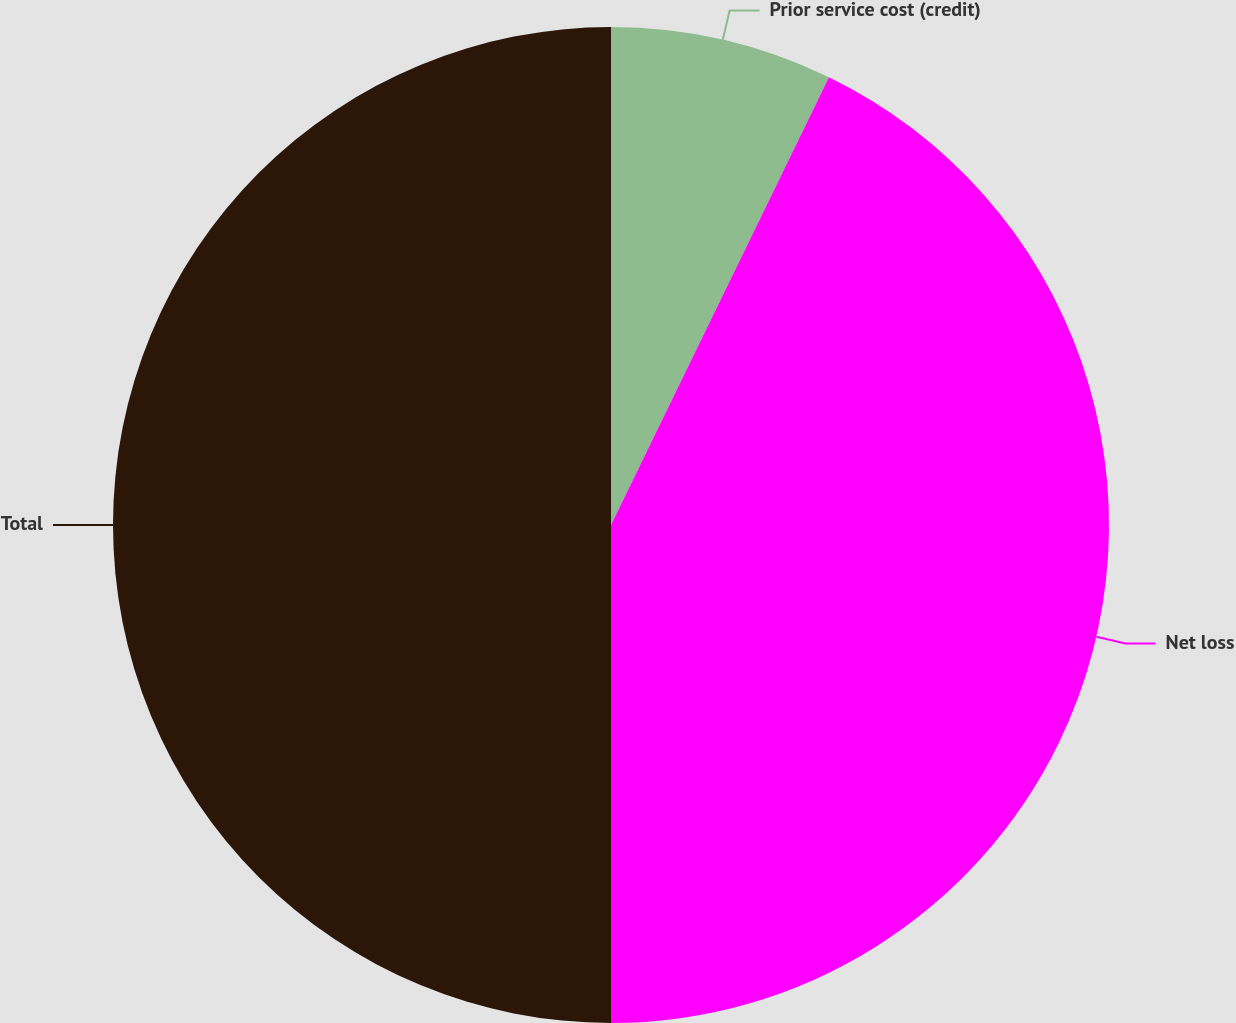Convert chart to OTSL. <chart><loc_0><loc_0><loc_500><loc_500><pie_chart><fcel>Prior service cost (credit)<fcel>Net loss<fcel>Total<nl><fcel>7.21%<fcel>42.79%<fcel>50.0%<nl></chart> 